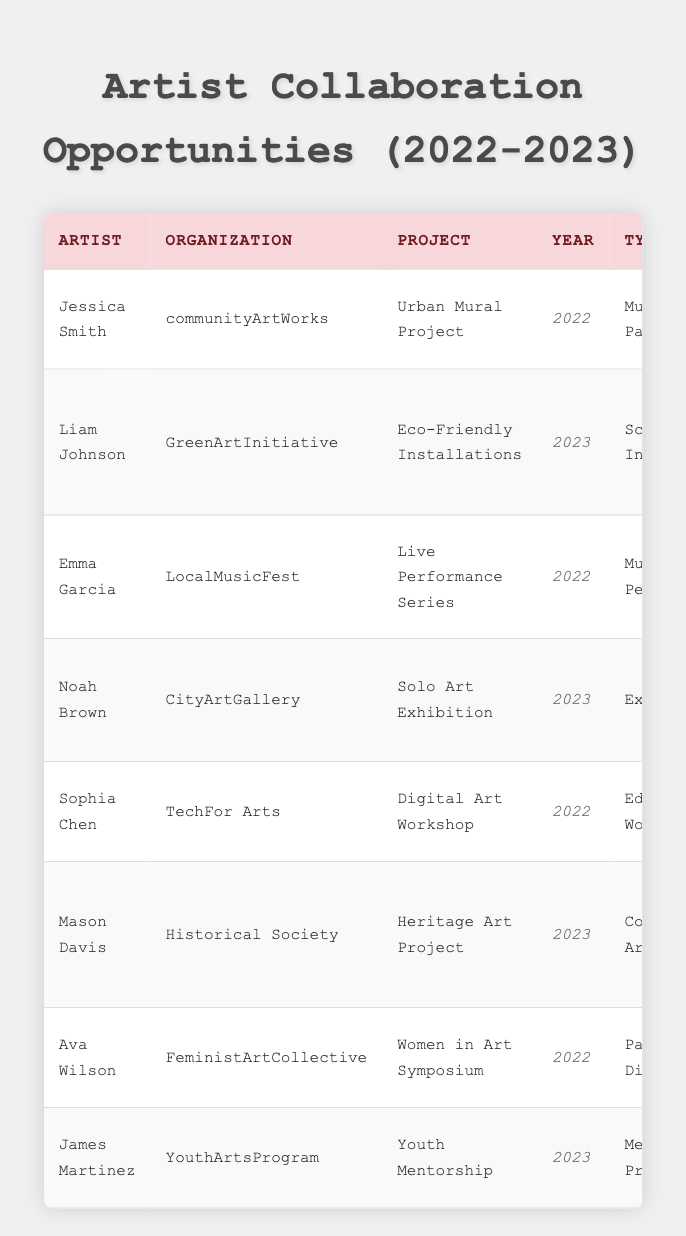What is the project title for the collaboration by Jessica Smith? The table lists the projects under the artist's name, and for Jessica Smith, the project title is "Urban Mural Project."
Answer: Urban Mural Project How much funding was provided for the "Digital Art Workshop"? The funding amount associated with the "Digital Art Workshop" project is found in the row for Sophia Chen, which states a funding amount of $5,000.
Answer: $5,000 Which artist collaborated with "GreenArtInitiative"? Looking at the organization column, Liam Johnson is associated with "GreenArtInitiative" for the project "Eco-Friendly Installations."
Answer: Liam Johnson What was the output of the collaboration with "LocalMusicFest"? The output for the project "Live Performance Series" with "LocalMusicFest" is detailed in the table, indicating "Two live performances during the festival."
Answer: Two live performances during the festival How many funding amounts were above $10,000? Upon reviewing the funding amounts, the ones above $10,000 are $15,000, $25,000, and $12,000. Adding these gives us a total of three instances above that mark.
Answer: 3 What type of collaboration did Ava Wilson participate in? The type of collaboration for Ava Wilson is listed as "Panel Discussion" under the project "Women in Art Symposium."
Answer: Panel Discussion What was the total funding amount from collaborations in 2023? To find the total for 2023, we extract the funding amounts: $25,000 (Liam Johnson) + $12,000 (Noah Brown) + $10,000 (Mason Davis) + $6,000 (James Martinez). Adding these amounts gives $53,000.
Answer: $53,000 Was there any educational workshop organized in 2023? By reviewing the table, we see that the only educational workshop listed is for 2022 (Sophia Chen, "Digital Art Workshop"). Therefore, there were no educational workshops in 2023.
Answer: No Which organization had the highest funding amount and what was it? Scanning through the funding amounts, "GreenArtInitiative" provided the highest amount, which was $25,000 for the project "Eco-Friendly Installations."
Answer: GreenArtInitiative, $25,000 How many artists worked in California, and who are they? Checking the location column for California, we find projects in Los Angeles (Sophia Chen) and San Francisco (Liam Johnson). Thus, there are two artists that collaborated in California, both of whom are mentioned.
Answer: 2, Sophia Chen and Liam Johnson What is the difference in funding between the 2022 projects and the 2023 projects? For 2022, the funding amounts are $15,000 (Jessica Smith) + $8,000 (Emma Garcia) + $5,000 (Sophia Chen) + $7,000 (Ava Wilson), yielding a total of $35,000. The 2023 funding amounts are $25,000 (Liam Johnson) + $12,000 (Noah Brown) + $10,000 (Mason Davis) + $6,000 (James Martinez), totaling $53,000. The difference in funding is $53,000 - $35,000 = $18,000.
Answer: $18,000 